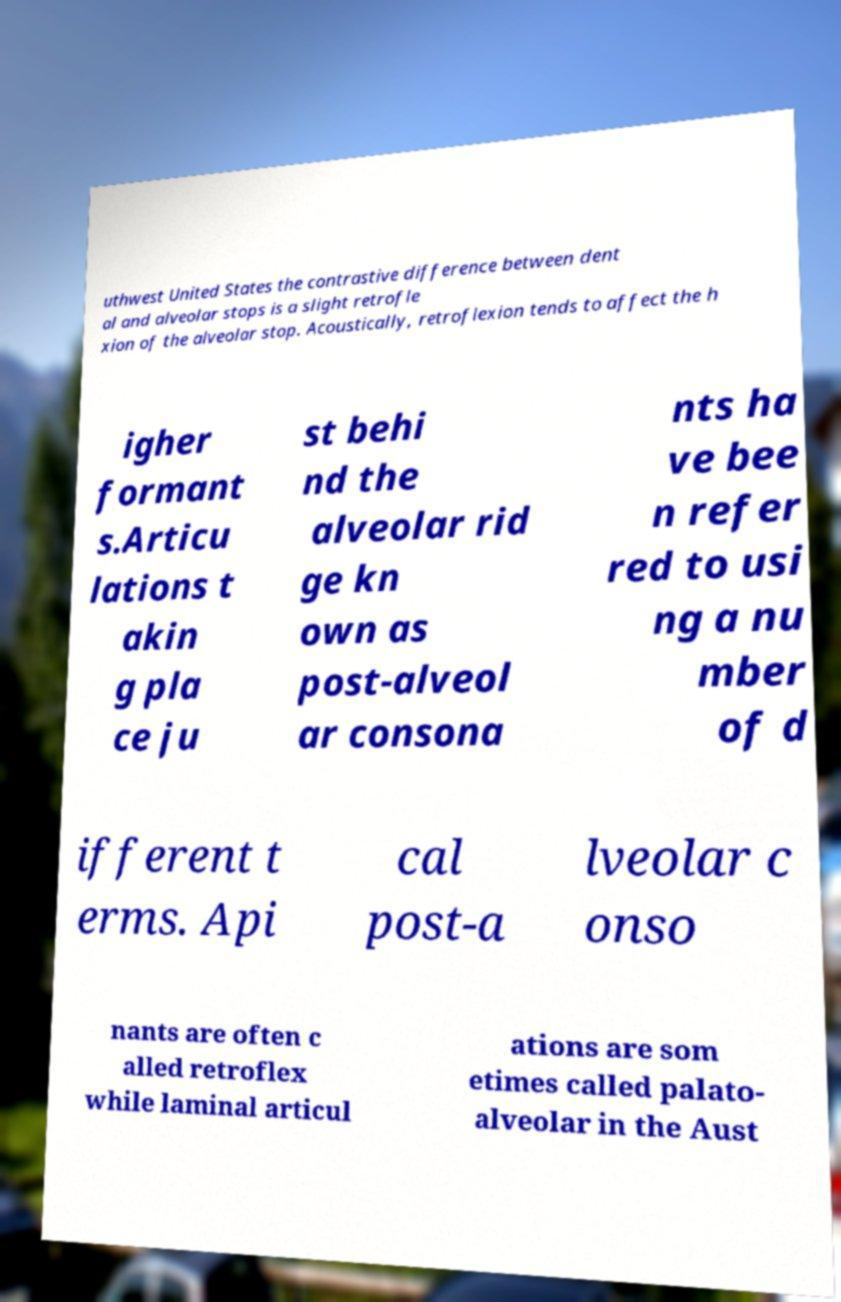What messages or text are displayed in this image? I need them in a readable, typed format. uthwest United States the contrastive difference between dent al and alveolar stops is a slight retrofle xion of the alveolar stop. Acoustically, retroflexion tends to affect the h igher formant s.Articu lations t akin g pla ce ju st behi nd the alveolar rid ge kn own as post-alveol ar consona nts ha ve bee n refer red to usi ng a nu mber of d ifferent t erms. Api cal post-a lveolar c onso nants are often c alled retroflex while laminal articul ations are som etimes called palato- alveolar in the Aust 